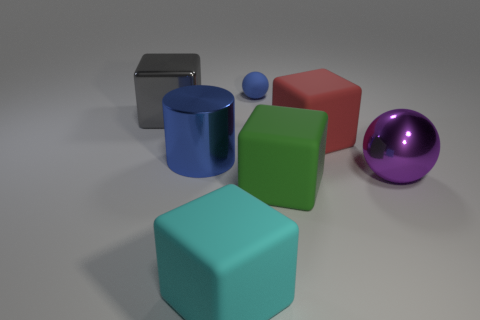Subtract all metallic cubes. How many cubes are left? 3 Add 1 blue objects. How many objects exist? 8 Subtract 2 spheres. How many spheres are left? 0 Subtract all cylinders. How many objects are left? 6 Subtract all tiny brown rubber things. Subtract all large red rubber things. How many objects are left? 6 Add 4 gray shiny cubes. How many gray shiny cubes are left? 5 Add 6 red matte cubes. How many red matte cubes exist? 7 Subtract all purple spheres. How many spheres are left? 1 Subtract 1 red cubes. How many objects are left? 6 Subtract all gray cylinders. Subtract all cyan blocks. How many cylinders are left? 1 